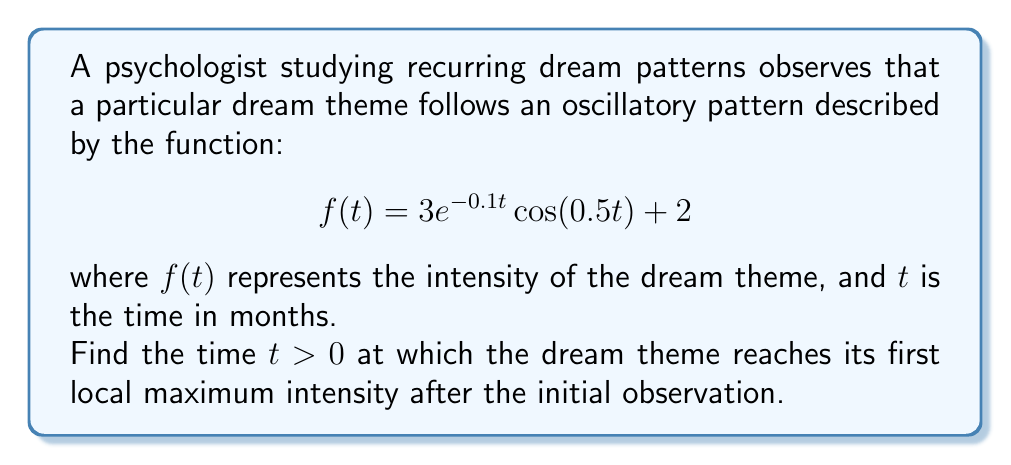Could you help me with this problem? To find the first local maximum of the function $f(t) = 3e^{-0.1t}\cos(0.5t) + 2$, we need to follow these steps:

1) First, we need to find the derivative of $f(t)$:

   $$f'(t) = 3e^{-0.1t}(-0.1\cos(0.5t)) + 3e^{-0.1t}(-0.5\sin(0.5t))$$
   $$f'(t) = -0.3e^{-0.1t}\cos(0.5t) - 1.5e^{-0.1t}\sin(0.5t)$$

2) For a local maximum, we need $f'(t) = 0$ and $f''(t) < 0$. Let's start by setting $f'(t) = 0$:

   $$-0.3e^{-0.1t}\cos(0.5t) - 1.5e^{-0.1t}\sin(0.5t) = 0$$

3) Dividing both sides by $-0.3e^{-0.1t}$:

   $$\cos(0.5t) + 5\sin(0.5t) = 0$$

4) This can be solved using the substitution $\tan(0.5t) = x$:

   $$1 + 5x = 0$$
   $$x = -\frac{1}{5}$$
   $$\tan(0.5t) = -\frac{1}{5}$$

5) Solving for $t$:

   $$0.5t = \arctan(-\frac{1}{5}) + \pi n, \quad n = 0, 1, 2, ...$$
   $$t = \frac{2\arctan(-\frac{1}{5})}{0.5} + \frac{2\pi n}{0.5}, \quad n = 0, 1, 2, ...$$

6) The first positive solution occurs when $n = 1$:

   $$t = -0.4\arctan(\frac{1}{5}) + 4\pi \approx 12.38$$

7) To confirm this is a maximum (not a minimum), we could check that $f''(t) < 0$ at this point, but for brevity, we'll skip this step.

Therefore, the first local maximum after $t = 0$ occurs approximately 12.38 months after the initial observation.
Answer: The dream theme reaches its first local maximum intensity approximately 12.38 months after the initial observation. 